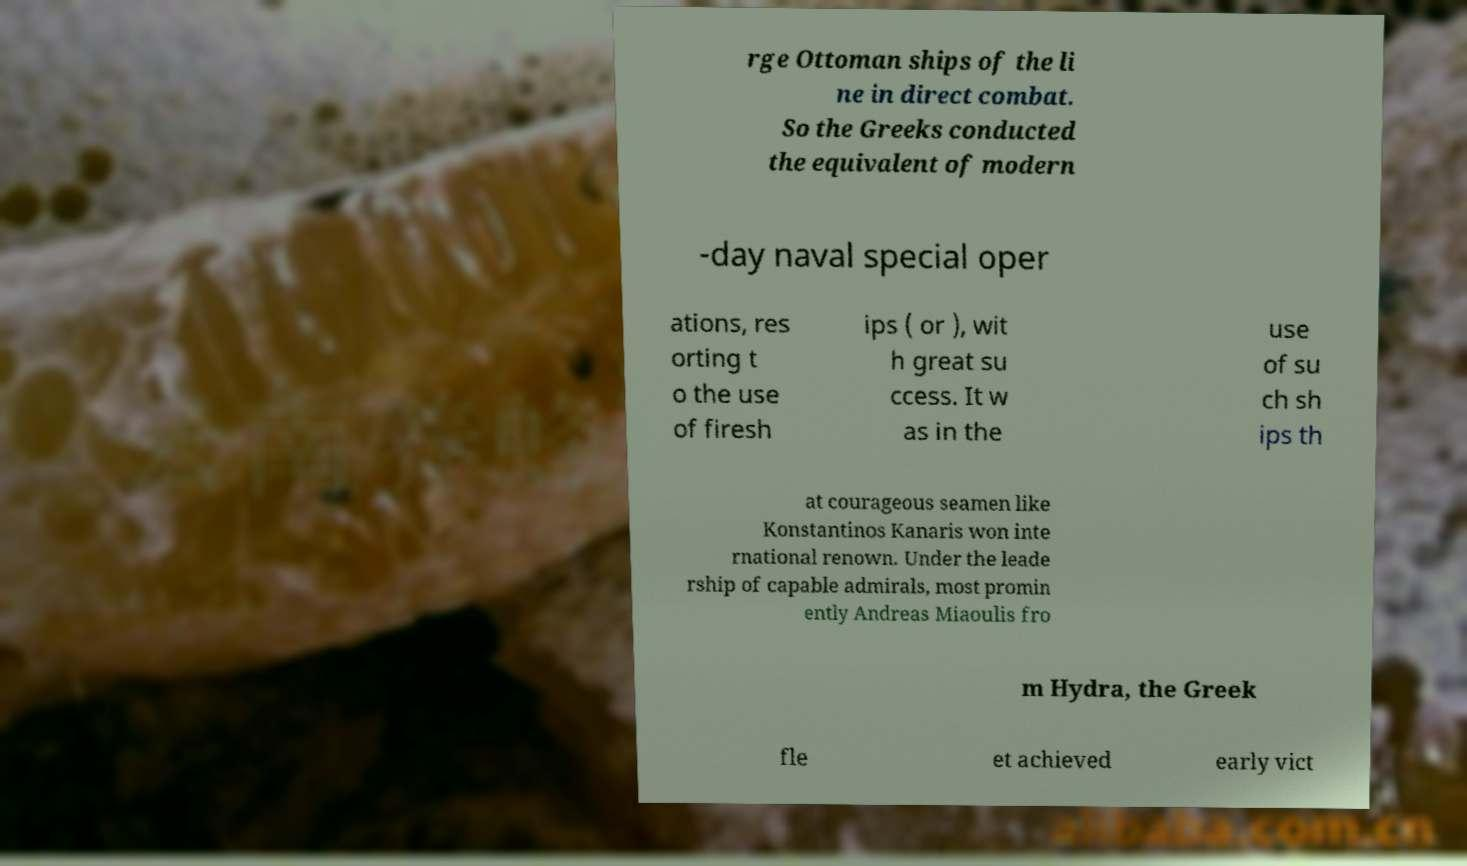Can you read and provide the text displayed in the image?This photo seems to have some interesting text. Can you extract and type it out for me? rge Ottoman ships of the li ne in direct combat. So the Greeks conducted the equivalent of modern -day naval special oper ations, res orting t o the use of firesh ips ( or ), wit h great su ccess. It w as in the use of su ch sh ips th at courageous seamen like Konstantinos Kanaris won inte rnational renown. Under the leade rship of capable admirals, most promin ently Andreas Miaoulis fro m Hydra, the Greek fle et achieved early vict 